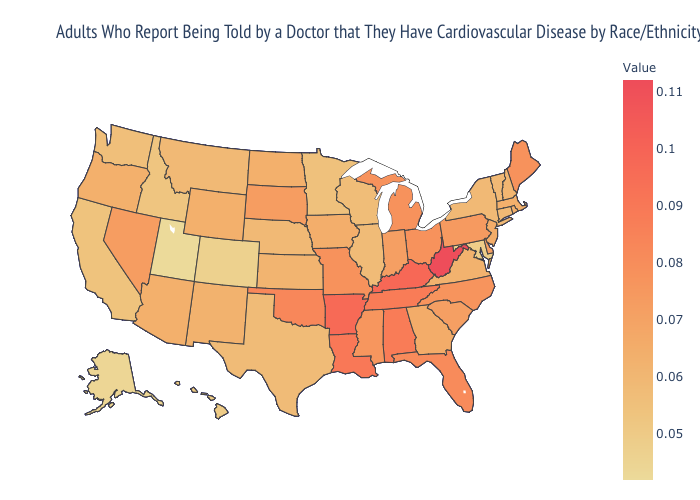Does Kentucky have a higher value than West Virginia?
Write a very short answer. No. Which states have the lowest value in the Northeast?
Give a very brief answer. Connecticut, New York, Vermont. 